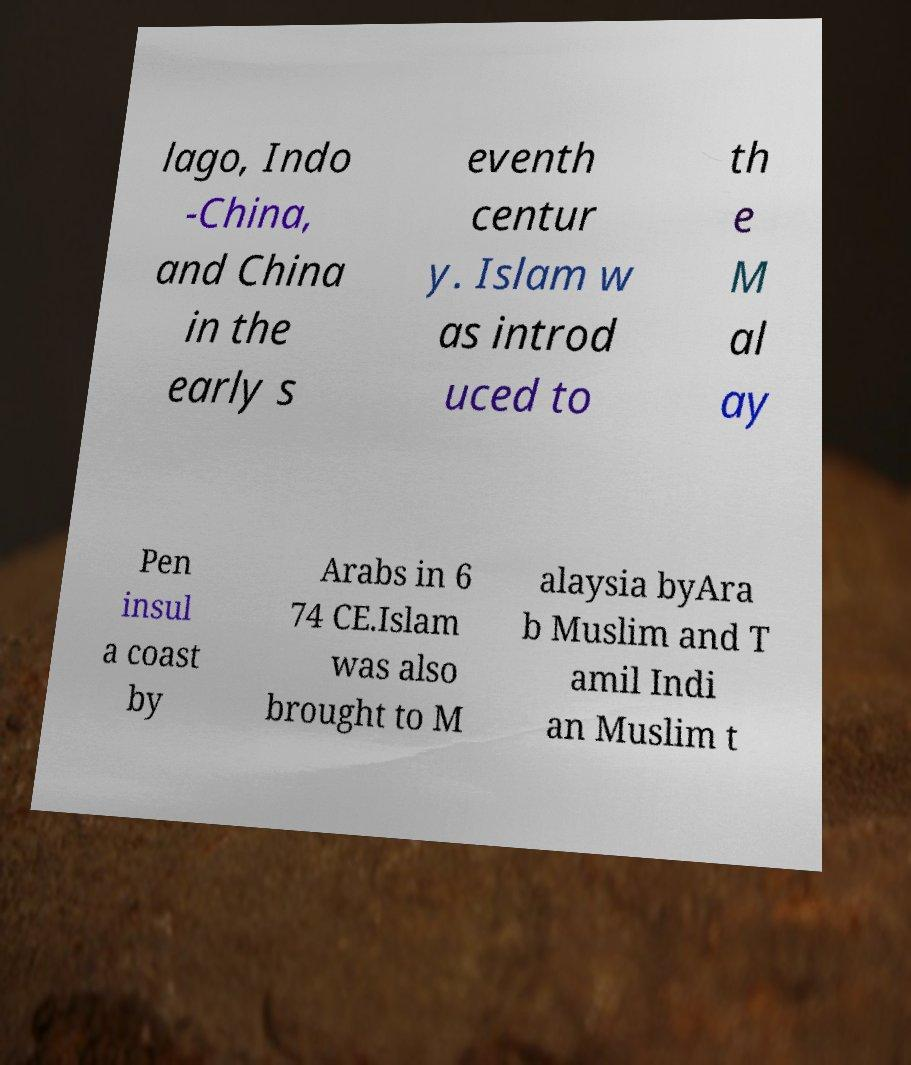There's text embedded in this image that I need extracted. Can you transcribe it verbatim? lago, Indo -China, and China in the early s eventh centur y. Islam w as introd uced to th e M al ay Pen insul a coast by Arabs in 6 74 CE.Islam was also brought to M alaysia byAra b Muslim and T amil Indi an Muslim t 